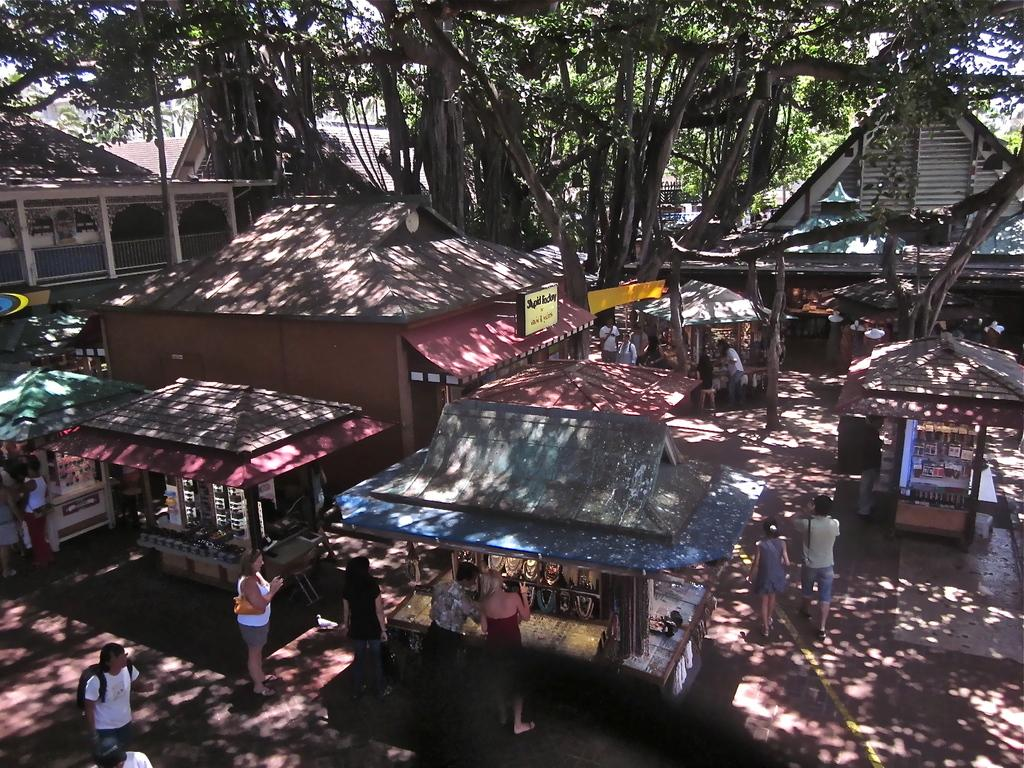What type of vehicles are in the image? There are ships in the image. Who or what else can be seen in the image? There are people and a tree in the image. What type of doctor is examining the tree in the image? There is no doctor present in the image, nor is there any indication that the tree is being examined. 